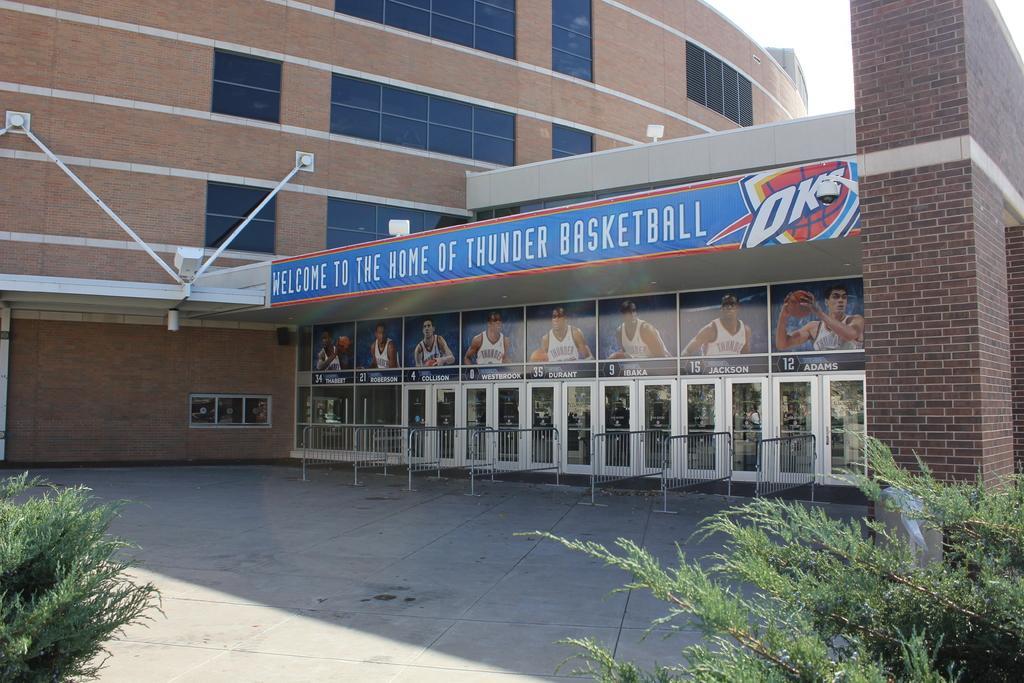Can you describe this image briefly? In this picture we can see the building. In the center we can see the entrance door and fencing. At the top of the door we can see the photos of a player who are wearing white t-shirt and some players are holding basketball. In the bottom right corner there is a plastic cover on the plant. In the top right there is a sky. On the left we can see the windows. 